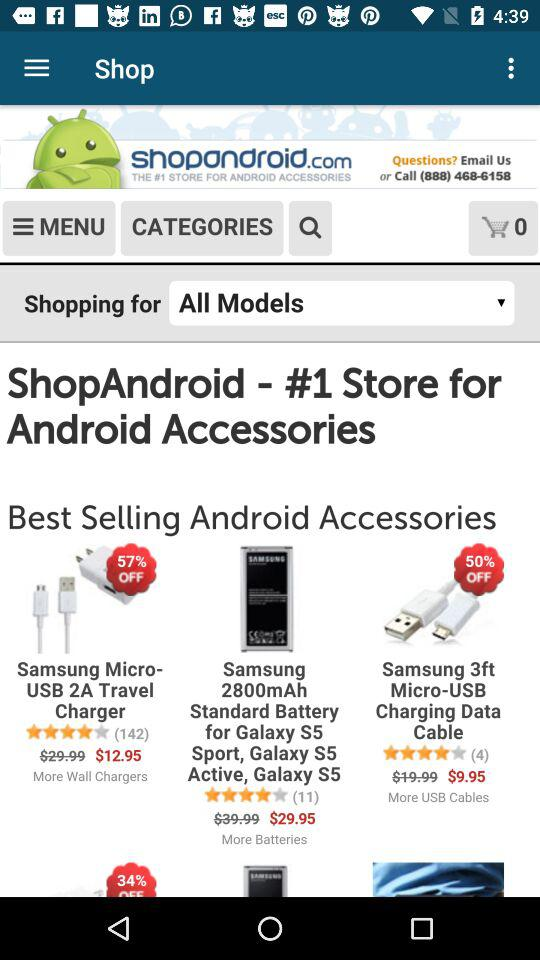How many ratings did "Samsung 2800mAh Standard Battery for Galaxy S5 Sport, Galaxy S5 Active, Galaxy S5" get? It got 11 ratings. 